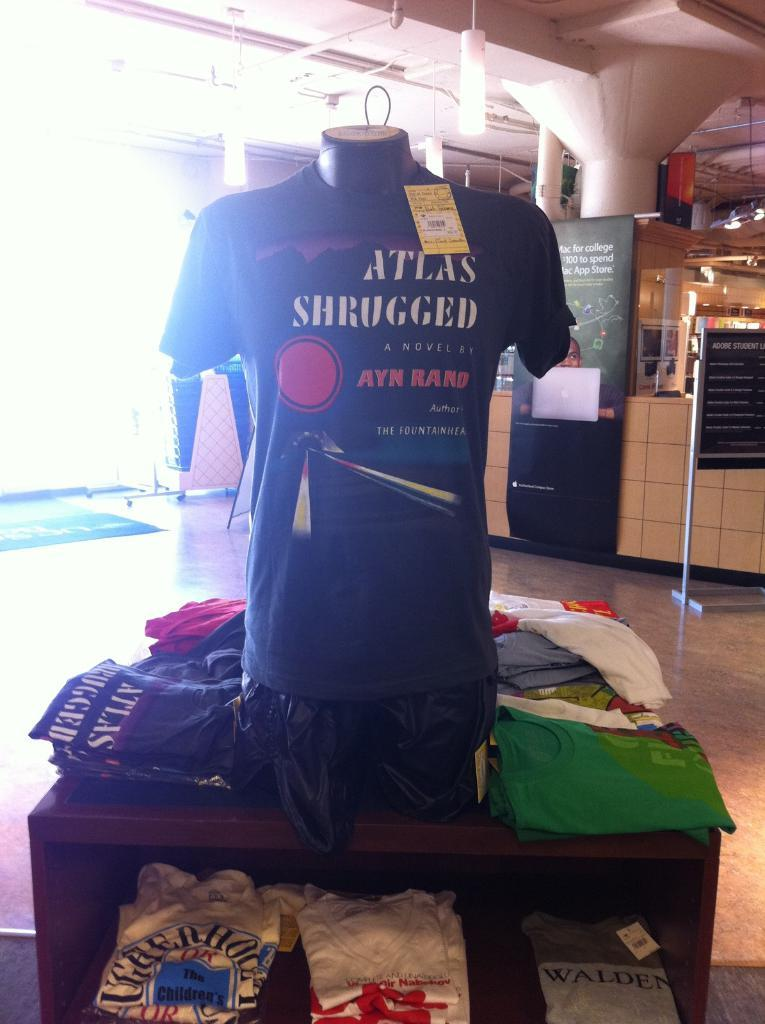<image>
Create a compact narrative representing the image presented. a shop with a t-shirt display for a shirt reading Atlas Shrugged 